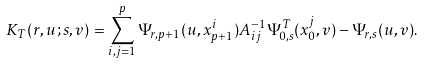<formula> <loc_0><loc_0><loc_500><loc_500>K _ { T } ( r , u ; s , v ) = \sum _ { i , j = 1 } ^ { p } \Psi _ { r , p + 1 } ( u , x _ { p + 1 } ^ { i } ) A ^ { - 1 } _ { i j } \Psi ^ { T } _ { 0 , s } ( x _ { 0 } ^ { j } , v ) - \Psi _ { r , s } ( u , v ) .</formula> 